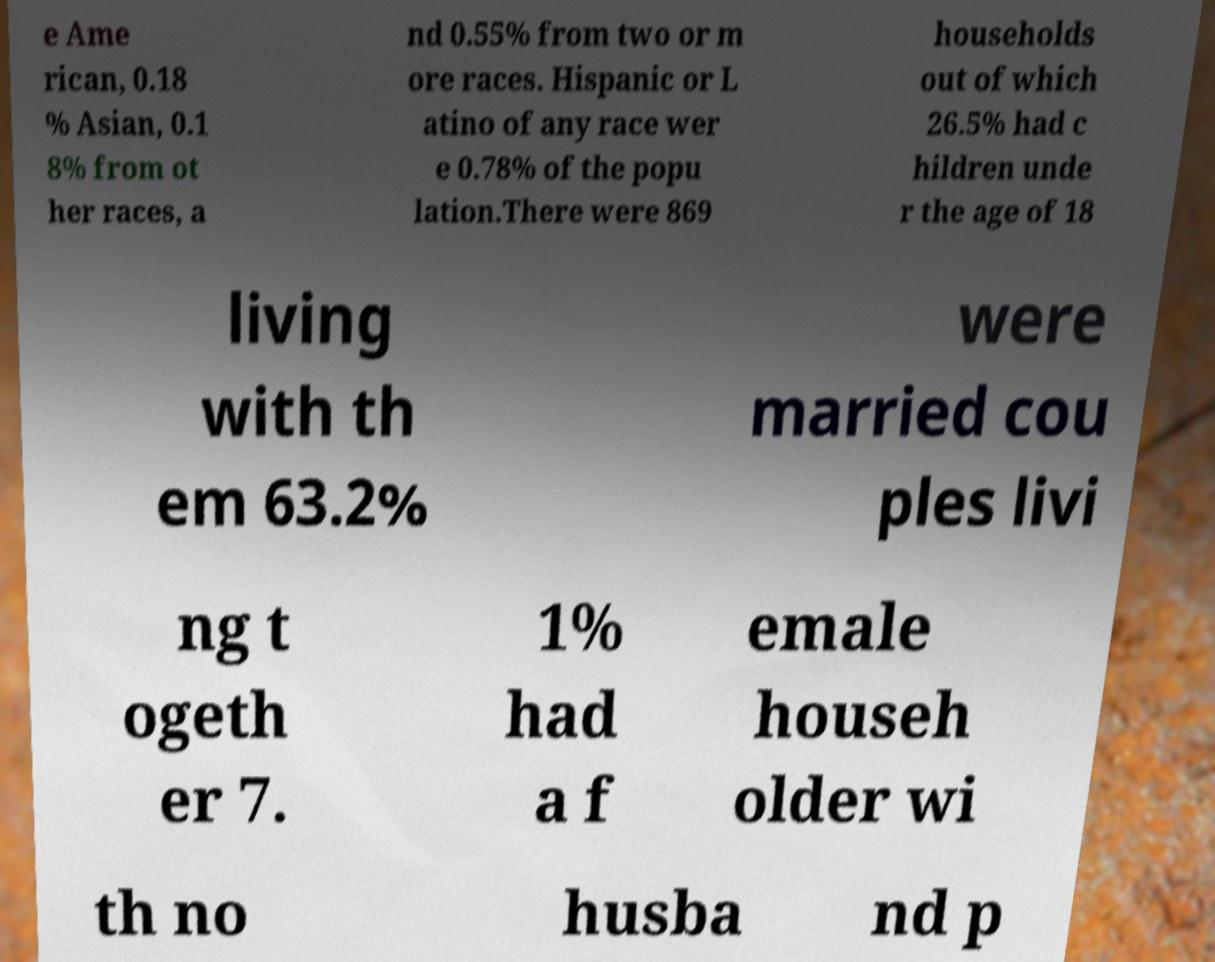There's text embedded in this image that I need extracted. Can you transcribe it verbatim? e Ame rican, 0.18 % Asian, 0.1 8% from ot her races, a nd 0.55% from two or m ore races. Hispanic or L atino of any race wer e 0.78% of the popu lation.There were 869 households out of which 26.5% had c hildren unde r the age of 18 living with th em 63.2% were married cou ples livi ng t ogeth er 7. 1% had a f emale househ older wi th no husba nd p 